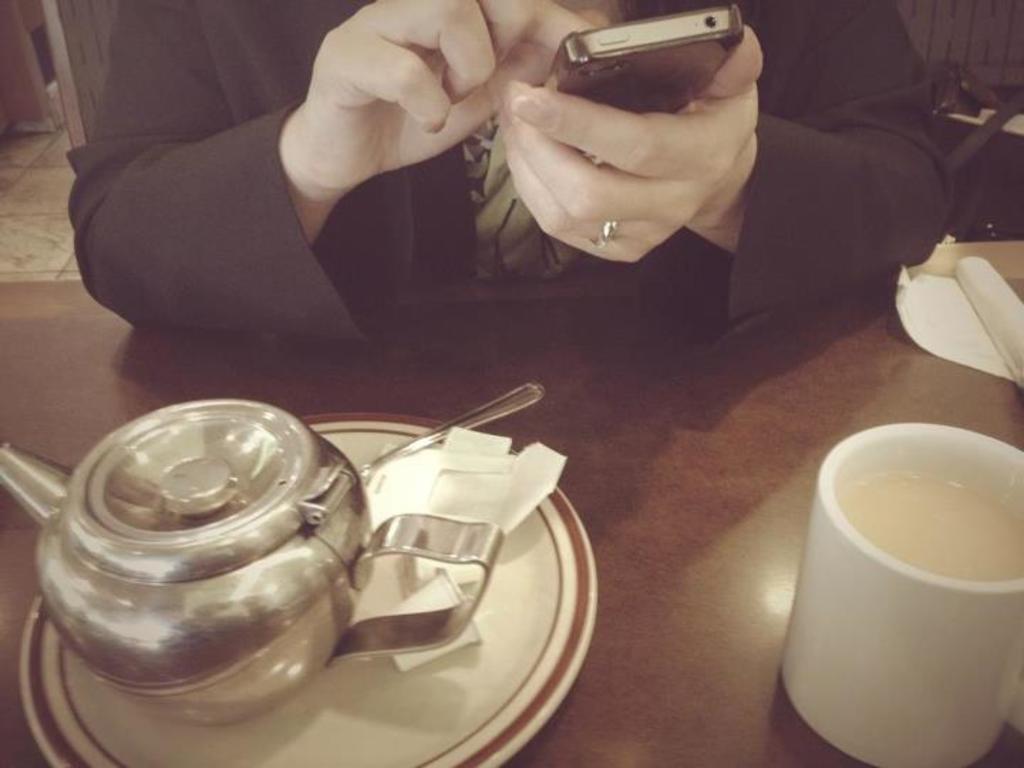In one or two sentences, can you explain what this image depicts? Here we can see a person holding a mobile phone in hand and we can see a cattle and Cup and a plate placed on the table present in front of her 